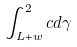<formula> <loc_0><loc_0><loc_500><loc_500>\int _ { L + w } ^ { 2 } c d \gamma</formula> 